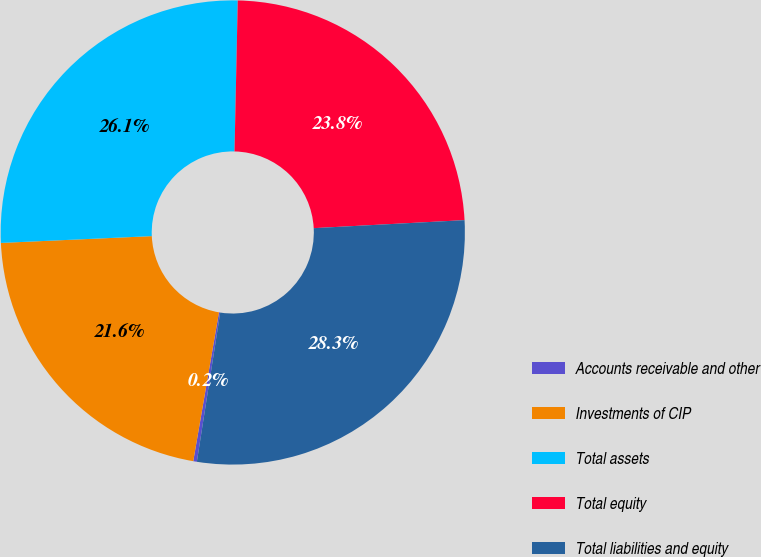<chart> <loc_0><loc_0><loc_500><loc_500><pie_chart><fcel>Accounts receivable and other<fcel>Investments of CIP<fcel>Total assets<fcel>Total equity<fcel>Total liabilities and equity<nl><fcel>0.25%<fcel>21.56%<fcel>26.06%<fcel>23.81%<fcel>28.32%<nl></chart> 